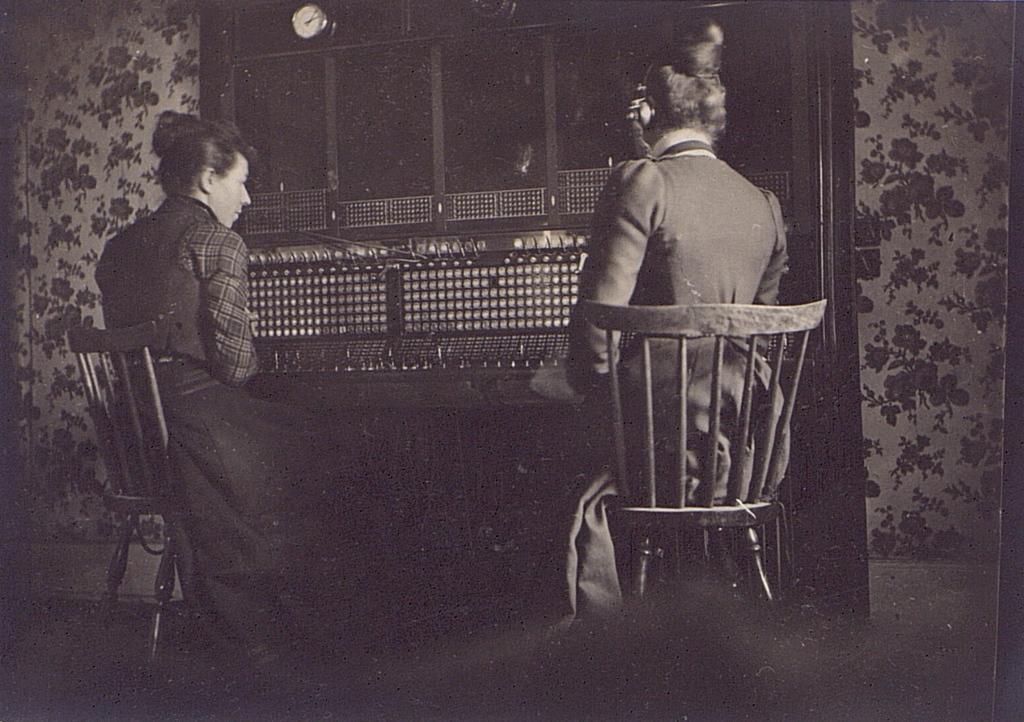Can you describe this image briefly? In this picture we can see two persons are seated on the chair, the right side person is wore a headset over the ear, in front of them we can find a watch and curtains. 